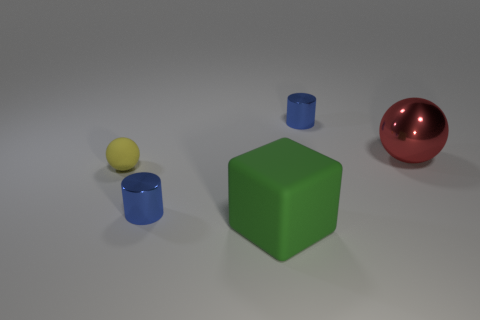Are the blue object behind the small rubber object and the small cylinder that is left of the green rubber object made of the same material?
Ensure brevity in your answer.  Yes. There is a thing that is in front of the tiny ball and to the left of the matte block; what is its shape?
Make the answer very short. Cylinder. Are there any other things that are the same material as the tiny yellow ball?
Provide a short and direct response. Yes. There is a small thing that is left of the green matte block and right of the yellow sphere; what is it made of?
Your answer should be very brief. Metal. The object that is the same material as the large block is what shape?
Give a very brief answer. Sphere. Are there any other things that are the same color as the rubber sphere?
Your answer should be compact. No. Are there more large rubber cubes that are in front of the rubber cube than large purple matte things?
Provide a short and direct response. No. What is the material of the large ball?
Ensure brevity in your answer.  Metal. How many other cubes are the same size as the green block?
Your response must be concise. 0. Is the number of big green objects that are left of the large matte object the same as the number of green rubber things that are on the left side of the big red sphere?
Your answer should be compact. No. 